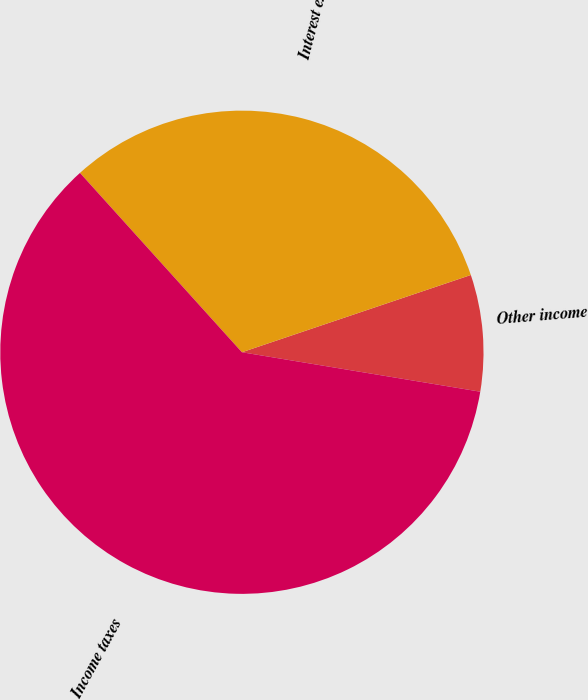Convert chart. <chart><loc_0><loc_0><loc_500><loc_500><pie_chart><fcel>Other income<fcel>Interest expense<fcel>Income taxes<nl><fcel>7.79%<fcel>31.51%<fcel>60.7%<nl></chart> 